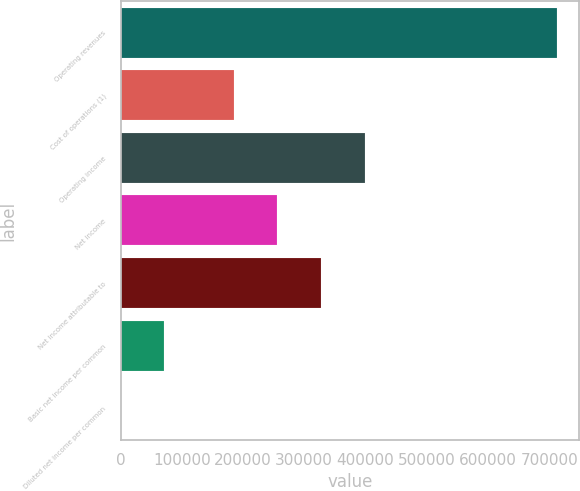Convert chart to OTSL. <chart><loc_0><loc_0><loc_500><loc_500><bar_chart><fcel>Operating revenues<fcel>Cost of operations (1)<fcel>Operating income<fcel>Net income<fcel>Net income attributable to<fcel>Basic net income per common<fcel>Diluted net income per common<nl><fcel>713335<fcel>184904<fcel>398904<fcel>256237<fcel>327571<fcel>71334<fcel>0.58<nl></chart> 